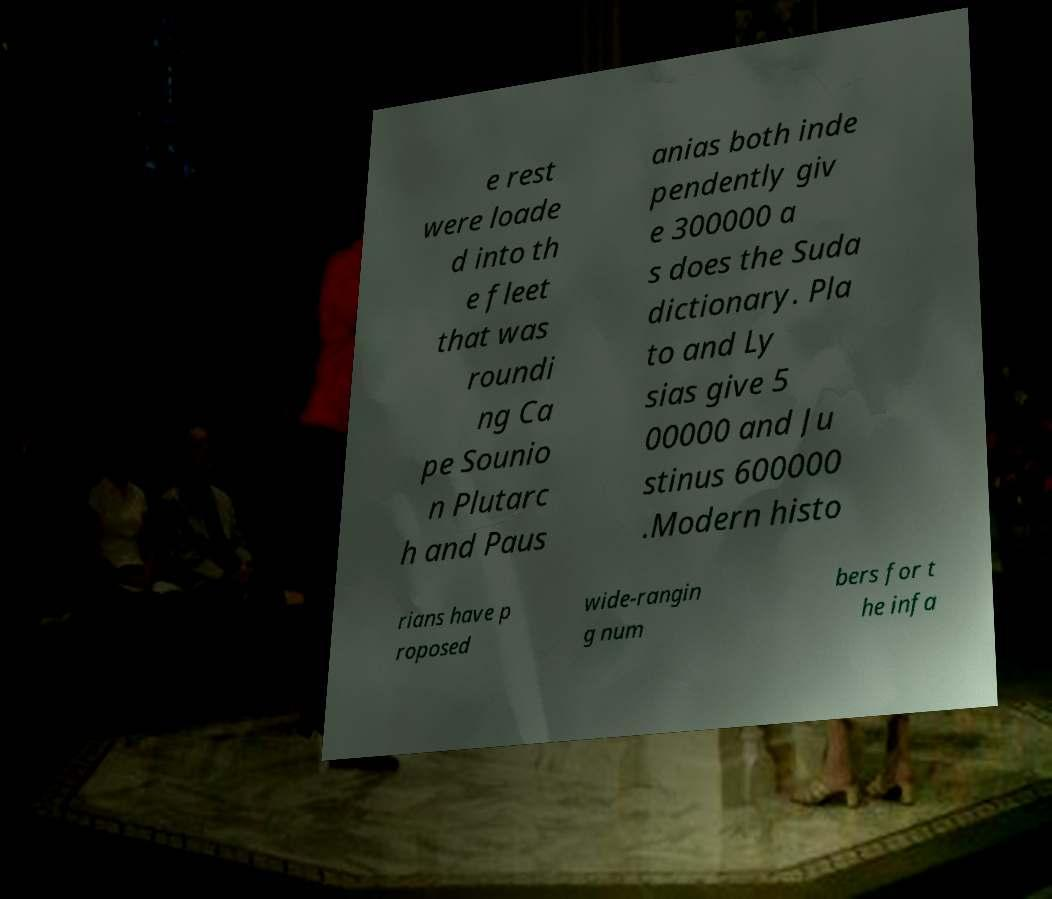What messages or text are displayed in this image? I need them in a readable, typed format. e rest were loade d into th e fleet that was roundi ng Ca pe Sounio n Plutarc h and Paus anias both inde pendently giv e 300000 a s does the Suda dictionary. Pla to and Ly sias give 5 00000 and Ju stinus 600000 .Modern histo rians have p roposed wide-rangin g num bers for t he infa 